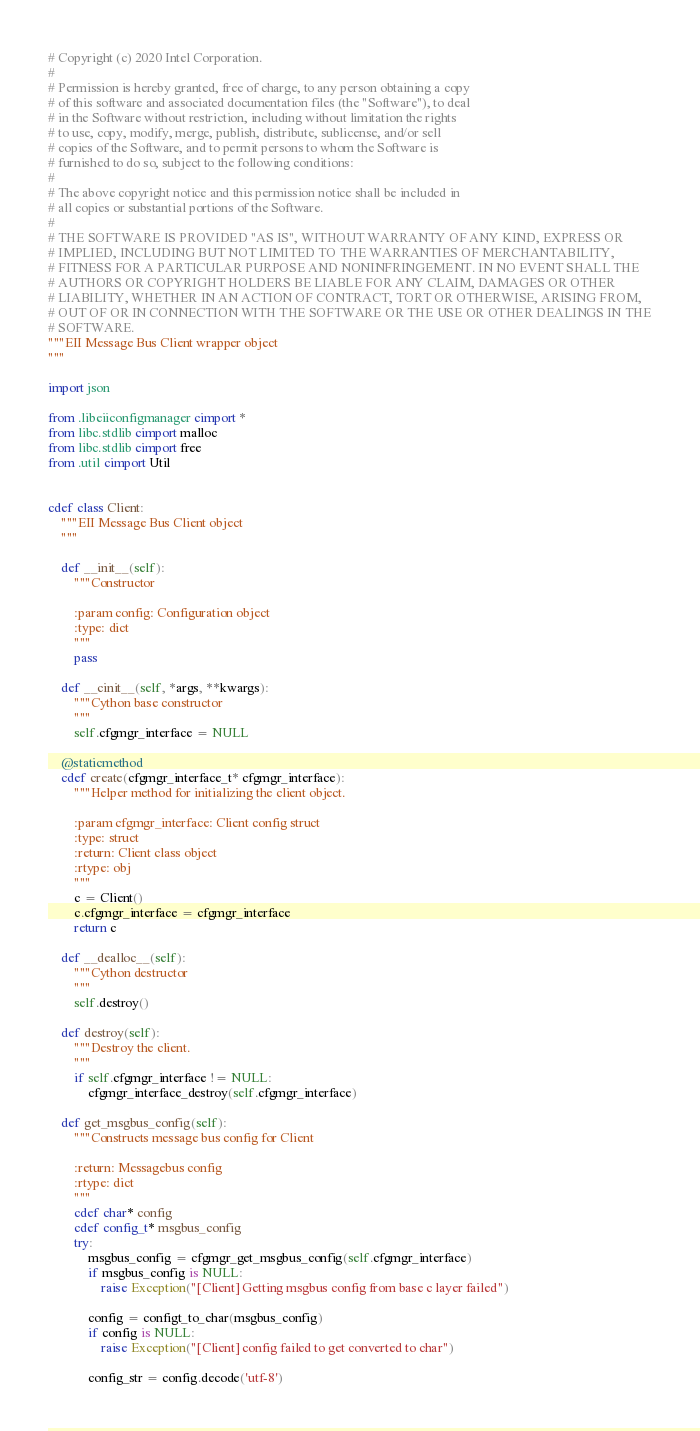<code> <loc_0><loc_0><loc_500><loc_500><_Cython_># Copyright (c) 2020 Intel Corporation.
#
# Permission is hereby granted, free of charge, to any person obtaining a copy
# of this software and associated documentation files (the "Software"), to deal
# in the Software without restriction, including without limitation the rights
# to use, copy, modify, merge, publish, distribute, sublicense, and/or sell
# copies of the Software, and to permit persons to whom the Software is
# furnished to do so, subject to the following conditions:
#
# The above copyright notice and this permission notice shall be included in
# all copies or substantial portions of the Software.
#
# THE SOFTWARE IS PROVIDED "AS IS", WITHOUT WARRANTY OF ANY KIND, EXPRESS OR
# IMPLIED, INCLUDING BUT NOT LIMITED TO THE WARRANTIES OF MERCHANTABILITY,
# FITNESS FOR A PARTICULAR PURPOSE AND NONINFRINGEMENT. IN NO EVENT SHALL THE
# AUTHORS OR COPYRIGHT HOLDERS BE LIABLE FOR ANY CLAIM, DAMAGES OR OTHER
# LIABILITY, WHETHER IN AN ACTION OF CONTRACT, TORT OR OTHERWISE, ARISING FROM,
# OUT OF OR IN CONNECTION WITH THE SOFTWARE OR THE USE OR OTHER DEALINGS IN THE
# SOFTWARE.
"""EII Message Bus Client wrapper object
"""

import json

from .libeiiconfigmanager cimport *
from libc.stdlib cimport malloc
from libc.stdlib cimport free
from .util cimport Util


cdef class Client:
    """EII Message Bus Client object
    """

    def __init__(self):
        """Constructor

        :param config: Configuration object
        :type: dict
        """
        pass

    def __cinit__(self, *args, **kwargs):
        """Cython base constructor
        """
        self.cfgmgr_interface = NULL

    @staticmethod
    cdef create(cfgmgr_interface_t* cfgmgr_interface):
        """Helper method for initializing the client object.

        :param cfgmgr_interface: Client config struct
        :type: struct
        :return: Client class object
        :rtype: obj
        """
        c = Client()
        c.cfgmgr_interface = cfgmgr_interface
        return c

    def __dealloc__(self):
        """Cython destructor
        """
        self.destroy()

    def destroy(self):
        """Destroy the client.
        """
        if self.cfgmgr_interface != NULL:
            cfgmgr_interface_destroy(self.cfgmgr_interface)

    def get_msgbus_config(self):
        """Constructs message bus config for Client

        :return: Messagebus config
        :rtype: dict
        """
        cdef char* config
        cdef config_t* msgbus_config
        try:
            msgbus_config = cfgmgr_get_msgbus_config(self.cfgmgr_interface)
            if msgbus_config is NULL:
                raise Exception("[Client] Getting msgbus config from base c layer failed")
        
            config = configt_to_char(msgbus_config)
            if config is NULL:
                raise Exception("[Client] config failed to get converted to char")

            config_str = config.decode('utf-8')</code> 